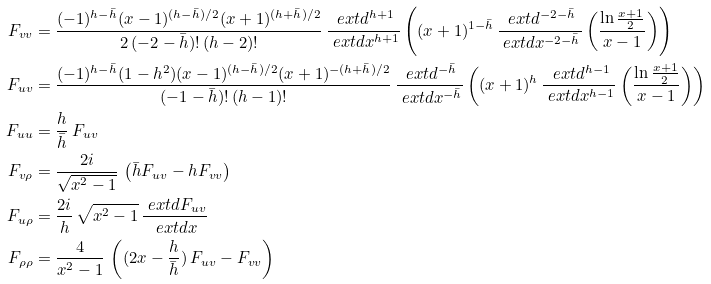Convert formula to latex. <formula><loc_0><loc_0><loc_500><loc_500>F _ { v v } & = \frac { ( - 1 ) ^ { h - \bar { h } } ( x - 1 ) ^ { ( h - \bar { h } ) / 2 } ( x + 1 ) ^ { ( h + \bar { h } ) / 2 } } { 2 \, ( - 2 - \bar { h } ) ! \, ( h - 2 ) ! } \, \frac { \ e x t d ^ { h + 1 } } { \ e x t d x ^ { h + 1 } } \left ( ( x + 1 ) ^ { 1 - \bar { h } } \, \frac { \ e x t d ^ { - 2 - \bar { h } } } { \ e x t d x ^ { - 2 - \bar { h } } } \left ( \frac { \ln { \frac { x + 1 } { 2 } } } { x - 1 } \right ) \right ) \\ F _ { u v } & = \frac { ( - 1 ) ^ { h - \bar { h } } ( 1 - h ^ { 2 } ) ( x - 1 ) ^ { ( h - \bar { h } ) / 2 } ( x + 1 ) ^ { - ( h + \bar { h } ) / 2 } } { ( - 1 - \bar { h } ) ! \, ( h - 1 ) ! } \, \frac { \ e x t d ^ { - \bar { h } } } { \ e x t d x ^ { - \bar { h } } } \left ( ( x + 1 ) ^ { h } \, \frac { \ e x t d ^ { h - 1 } } { \ e x t d x ^ { h - 1 } } \left ( \frac { \ln { \frac { x + 1 } { 2 } } } { x - 1 } \right ) \right ) \\ F _ { u u } & = \frac { h } { \bar { h } } \, F _ { u v } \\ F _ { v \rho } & = \frac { 2 i } { \sqrt { x ^ { 2 } - 1 } } \, \left ( \bar { h } F _ { u v } - h F _ { v v } \right ) \\ F _ { u \rho } & = \frac { 2 i } { h } \, \sqrt { x ^ { 2 } - 1 } \, \frac { \ e x t d F _ { u v } } { \ e x t d x } \\ F _ { \rho \rho } & = \frac { 4 } { x ^ { 2 } - 1 } \, \left ( ( 2 x - \frac { h } { \bar { h } } ) \, F _ { u v } - F _ { v v } \right )</formula> 